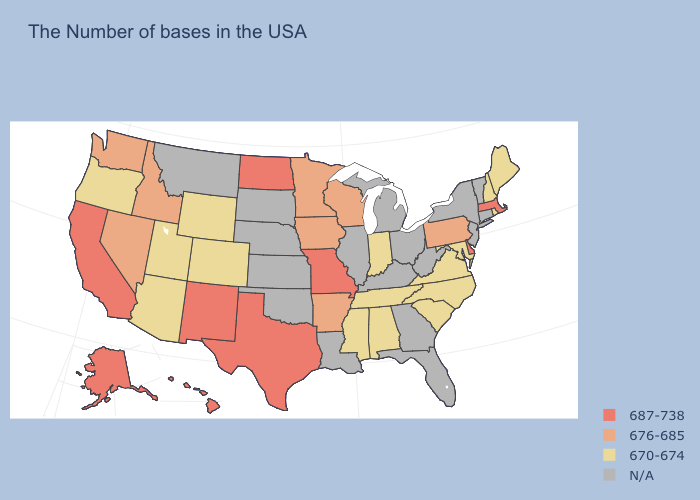Name the states that have a value in the range 687-738?
Keep it brief. Massachusetts, Delaware, Missouri, Texas, North Dakota, New Mexico, California, Alaska, Hawaii. What is the value of Tennessee?
Write a very short answer. 670-674. Name the states that have a value in the range 687-738?
Short answer required. Massachusetts, Delaware, Missouri, Texas, North Dakota, New Mexico, California, Alaska, Hawaii. What is the value of Rhode Island?
Short answer required. 670-674. What is the lowest value in the USA?
Write a very short answer. 670-674. What is the highest value in the USA?
Give a very brief answer. 687-738. What is the value of Idaho?
Write a very short answer. 676-685. What is the value of Maryland?
Be succinct. 670-674. Does Nevada have the highest value in the USA?
Quick response, please. No. Name the states that have a value in the range N/A?
Short answer required. Vermont, Connecticut, New York, New Jersey, West Virginia, Ohio, Florida, Georgia, Michigan, Kentucky, Illinois, Louisiana, Kansas, Nebraska, Oklahoma, South Dakota, Montana. What is the highest value in the USA?
Give a very brief answer. 687-738. Does Massachusetts have the highest value in the Northeast?
Short answer required. Yes. Is the legend a continuous bar?
Quick response, please. No. Name the states that have a value in the range 687-738?
Quick response, please. Massachusetts, Delaware, Missouri, Texas, North Dakota, New Mexico, California, Alaska, Hawaii. 